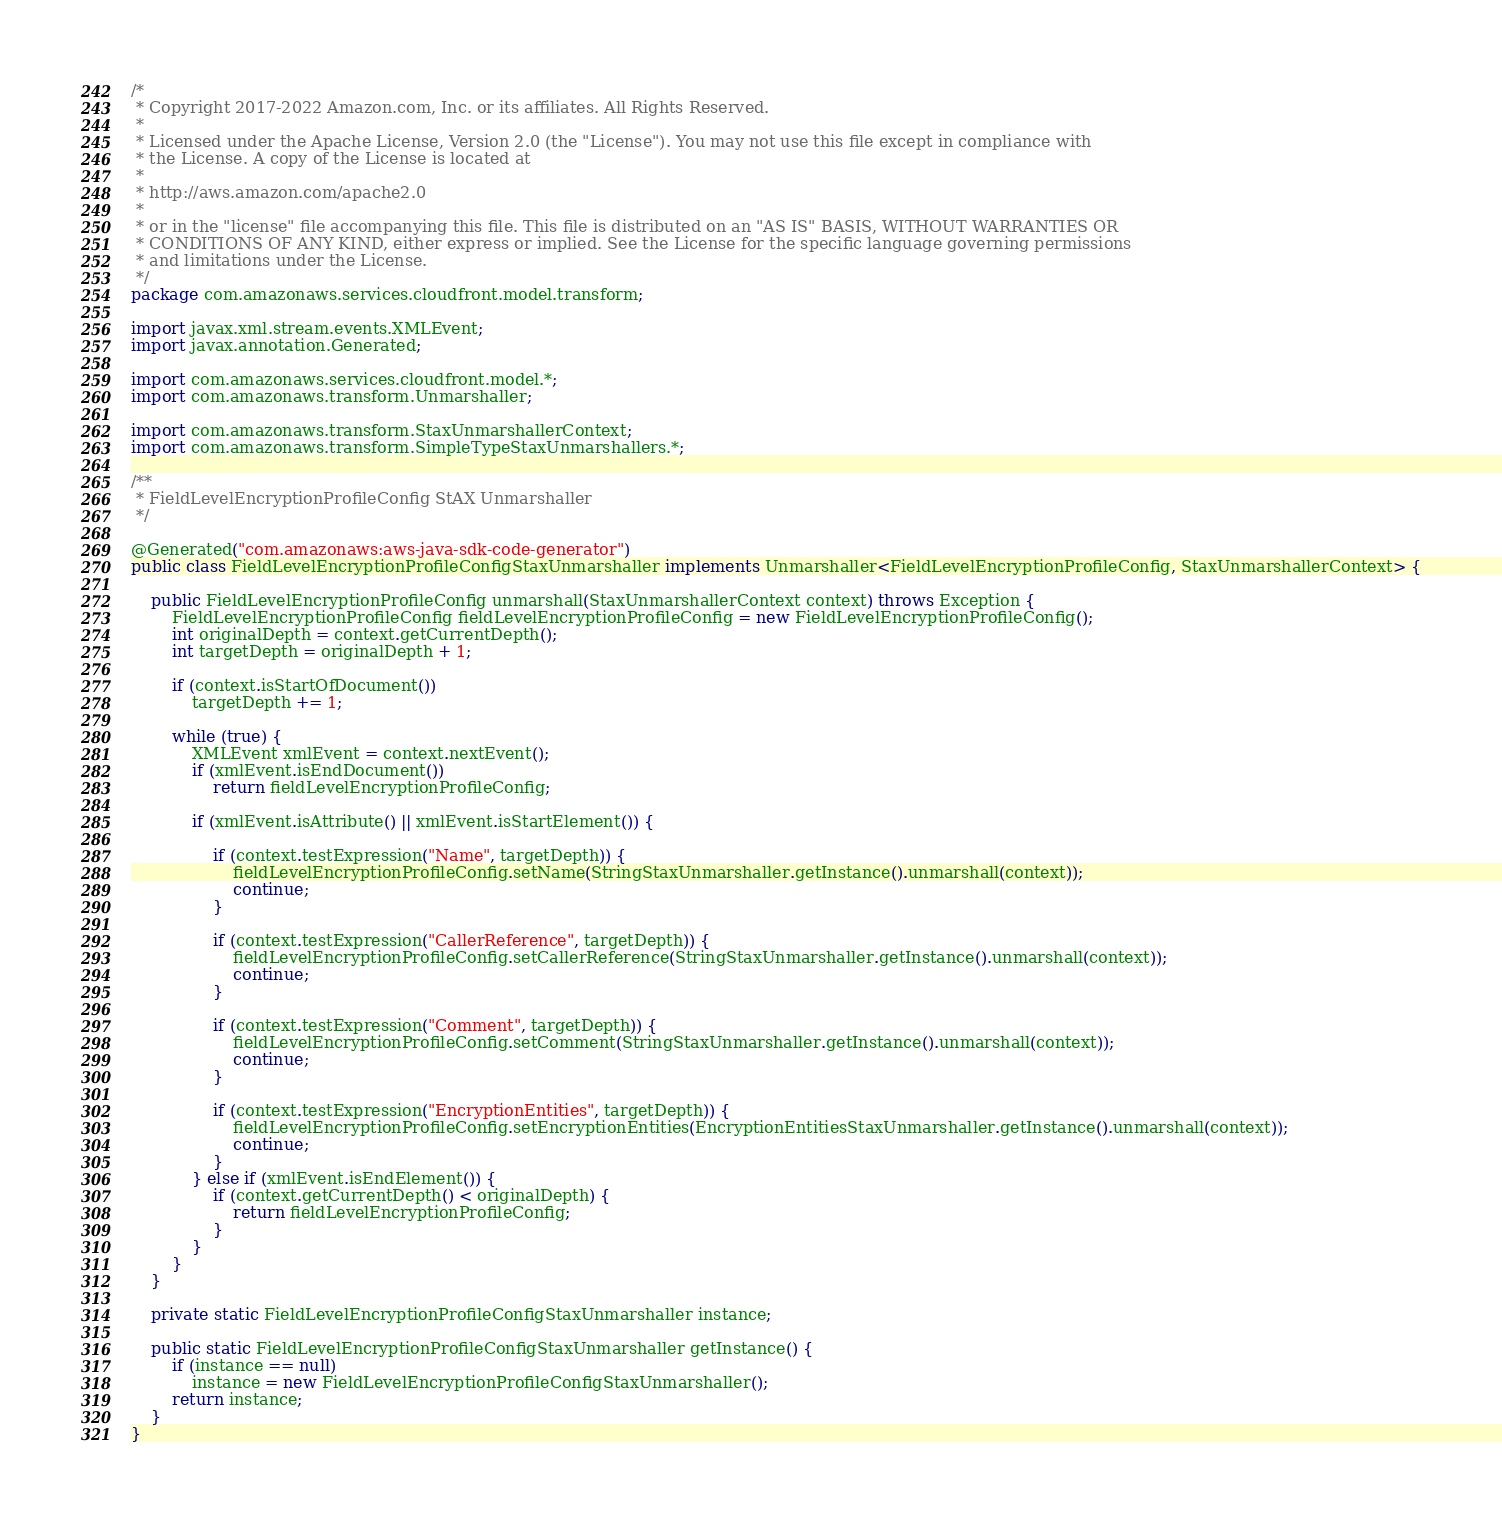Convert code to text. <code><loc_0><loc_0><loc_500><loc_500><_Java_>/*
 * Copyright 2017-2022 Amazon.com, Inc. or its affiliates. All Rights Reserved.
 * 
 * Licensed under the Apache License, Version 2.0 (the "License"). You may not use this file except in compliance with
 * the License. A copy of the License is located at
 * 
 * http://aws.amazon.com/apache2.0
 * 
 * or in the "license" file accompanying this file. This file is distributed on an "AS IS" BASIS, WITHOUT WARRANTIES OR
 * CONDITIONS OF ANY KIND, either express or implied. See the License for the specific language governing permissions
 * and limitations under the License.
 */
package com.amazonaws.services.cloudfront.model.transform;

import javax.xml.stream.events.XMLEvent;
import javax.annotation.Generated;

import com.amazonaws.services.cloudfront.model.*;
import com.amazonaws.transform.Unmarshaller;

import com.amazonaws.transform.StaxUnmarshallerContext;
import com.amazonaws.transform.SimpleTypeStaxUnmarshallers.*;

/**
 * FieldLevelEncryptionProfileConfig StAX Unmarshaller
 */

@Generated("com.amazonaws:aws-java-sdk-code-generator")
public class FieldLevelEncryptionProfileConfigStaxUnmarshaller implements Unmarshaller<FieldLevelEncryptionProfileConfig, StaxUnmarshallerContext> {

    public FieldLevelEncryptionProfileConfig unmarshall(StaxUnmarshallerContext context) throws Exception {
        FieldLevelEncryptionProfileConfig fieldLevelEncryptionProfileConfig = new FieldLevelEncryptionProfileConfig();
        int originalDepth = context.getCurrentDepth();
        int targetDepth = originalDepth + 1;

        if (context.isStartOfDocument())
            targetDepth += 1;

        while (true) {
            XMLEvent xmlEvent = context.nextEvent();
            if (xmlEvent.isEndDocument())
                return fieldLevelEncryptionProfileConfig;

            if (xmlEvent.isAttribute() || xmlEvent.isStartElement()) {

                if (context.testExpression("Name", targetDepth)) {
                    fieldLevelEncryptionProfileConfig.setName(StringStaxUnmarshaller.getInstance().unmarshall(context));
                    continue;
                }

                if (context.testExpression("CallerReference", targetDepth)) {
                    fieldLevelEncryptionProfileConfig.setCallerReference(StringStaxUnmarshaller.getInstance().unmarshall(context));
                    continue;
                }

                if (context.testExpression("Comment", targetDepth)) {
                    fieldLevelEncryptionProfileConfig.setComment(StringStaxUnmarshaller.getInstance().unmarshall(context));
                    continue;
                }

                if (context.testExpression("EncryptionEntities", targetDepth)) {
                    fieldLevelEncryptionProfileConfig.setEncryptionEntities(EncryptionEntitiesStaxUnmarshaller.getInstance().unmarshall(context));
                    continue;
                }
            } else if (xmlEvent.isEndElement()) {
                if (context.getCurrentDepth() < originalDepth) {
                    return fieldLevelEncryptionProfileConfig;
                }
            }
        }
    }

    private static FieldLevelEncryptionProfileConfigStaxUnmarshaller instance;

    public static FieldLevelEncryptionProfileConfigStaxUnmarshaller getInstance() {
        if (instance == null)
            instance = new FieldLevelEncryptionProfileConfigStaxUnmarshaller();
        return instance;
    }
}
</code> 